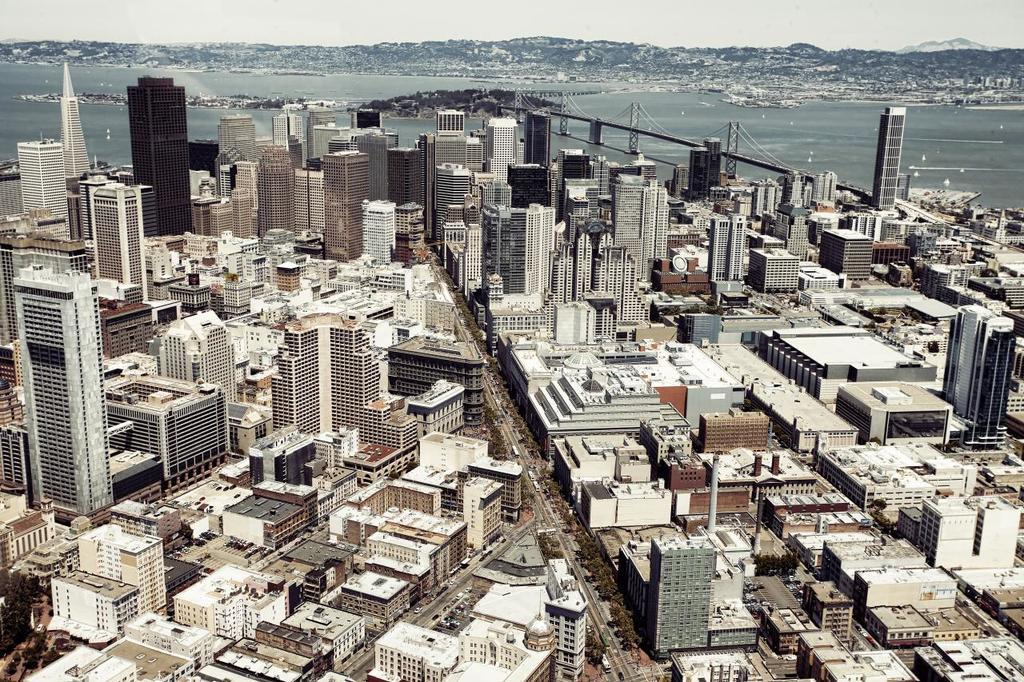What type of structures can be seen in the image? There are buildings in the image. What type of vegetation is at the bottom of the image? There are trees at the bottom of the image. What can be seen in the background of the image? There is water visible in the background of the image, and there is a bridge over the water. What type of lunch is being prepared by the creator in the image? There is no reference to lunch or a creator in the image, so it is not possible to answer that question. 